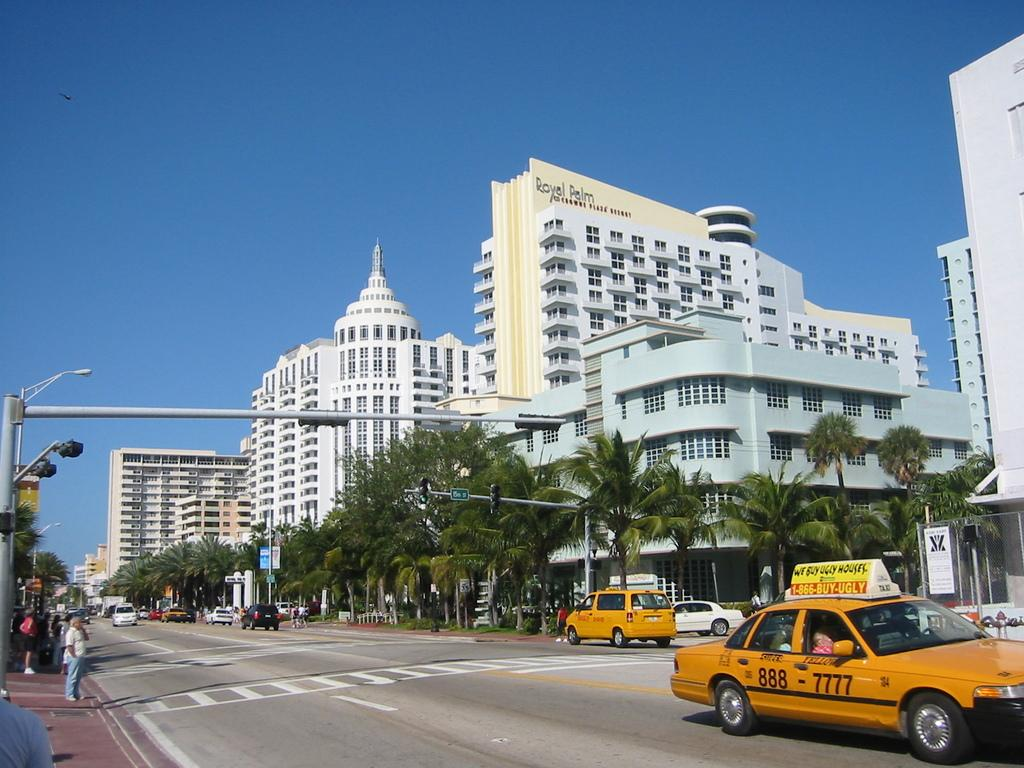<image>
Summarize the visual content of the image. A yellow taxi that has the number 888-7777 on it is going through a city intersection. 